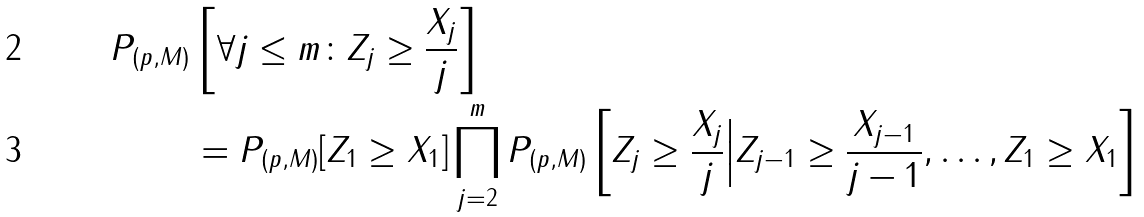<formula> <loc_0><loc_0><loc_500><loc_500>P _ { ( p , M ) } & \left [ \forall j \leq m \colon Z _ { j } \geq \frac { X _ { j } } { j } \right ] \\ & = P _ { ( p , M ) } [ Z _ { 1 } \geq X _ { 1 } ] \prod _ { j = 2 } ^ { m } P _ { ( p , M ) } \left [ Z _ { j } \geq \frac { X _ { j } } { j } \Big | Z _ { j - 1 } \geq \frac { X _ { j - 1 } } { j - 1 } , \dots , Z _ { 1 } \geq X _ { 1 } \right ]</formula> 